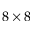<formula> <loc_0><loc_0><loc_500><loc_500>8 \times 8</formula> 